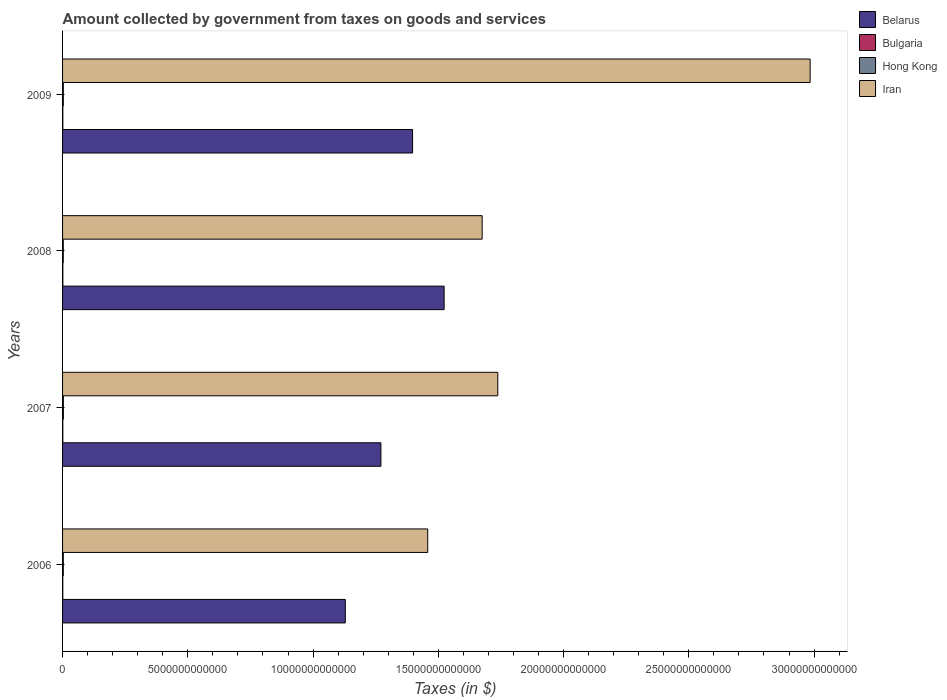How many different coloured bars are there?
Keep it short and to the point. 4. How many groups of bars are there?
Make the answer very short. 4. Are the number of bars per tick equal to the number of legend labels?
Your answer should be compact. Yes. How many bars are there on the 4th tick from the bottom?
Your response must be concise. 4. What is the amount collected by government from taxes on goods and services in Hong Kong in 2009?
Ensure brevity in your answer.  2.89e+1. Across all years, what is the maximum amount collected by government from taxes on goods and services in Bulgaria?
Keep it short and to the point. 1.17e+1. Across all years, what is the minimum amount collected by government from taxes on goods and services in Iran?
Give a very brief answer. 1.46e+13. In which year was the amount collected by government from taxes on goods and services in Belarus maximum?
Keep it short and to the point. 2008. In which year was the amount collected by government from taxes on goods and services in Iran minimum?
Offer a very short reply. 2006. What is the total amount collected by government from taxes on goods and services in Belarus in the graph?
Your response must be concise. 5.32e+13. What is the difference between the amount collected by government from taxes on goods and services in Bulgaria in 2007 and that in 2008?
Offer a terse response. -1.63e+09. What is the difference between the amount collected by government from taxes on goods and services in Iran in 2008 and the amount collected by government from taxes on goods and services in Bulgaria in 2007?
Offer a terse response. 1.67e+13. What is the average amount collected by government from taxes on goods and services in Bulgaria per year?
Keep it short and to the point. 1.02e+1. In the year 2008, what is the difference between the amount collected by government from taxes on goods and services in Hong Kong and amount collected by government from taxes on goods and services in Iran?
Your response must be concise. -1.67e+13. In how many years, is the amount collected by government from taxes on goods and services in Iran greater than 17000000000000 $?
Your answer should be compact. 2. What is the ratio of the amount collected by government from taxes on goods and services in Hong Kong in 2007 to that in 2008?
Your answer should be very brief. 1.12. Is the amount collected by government from taxes on goods and services in Belarus in 2006 less than that in 2009?
Ensure brevity in your answer.  Yes. Is the difference between the amount collected by government from taxes on goods and services in Hong Kong in 2006 and 2009 greater than the difference between the amount collected by government from taxes on goods and services in Iran in 2006 and 2009?
Make the answer very short. Yes. What is the difference between the highest and the second highest amount collected by government from taxes on goods and services in Belarus?
Offer a very short reply. 1.26e+12. What is the difference between the highest and the lowest amount collected by government from taxes on goods and services in Hong Kong?
Offer a terse response. 3.51e+09. In how many years, is the amount collected by government from taxes on goods and services in Iran greater than the average amount collected by government from taxes on goods and services in Iran taken over all years?
Offer a terse response. 1. Is the sum of the amount collected by government from taxes on goods and services in Bulgaria in 2006 and 2008 greater than the maximum amount collected by government from taxes on goods and services in Belarus across all years?
Keep it short and to the point. No. Is it the case that in every year, the sum of the amount collected by government from taxes on goods and services in Hong Kong and amount collected by government from taxes on goods and services in Bulgaria is greater than the sum of amount collected by government from taxes on goods and services in Belarus and amount collected by government from taxes on goods and services in Iran?
Offer a very short reply. No. What does the 2nd bar from the top in 2006 represents?
Provide a short and direct response. Hong Kong. What does the 1st bar from the bottom in 2007 represents?
Make the answer very short. Belarus. How many bars are there?
Make the answer very short. 16. Are all the bars in the graph horizontal?
Make the answer very short. Yes. What is the difference between two consecutive major ticks on the X-axis?
Your answer should be compact. 5.00e+12. Are the values on the major ticks of X-axis written in scientific E-notation?
Your answer should be very brief. No. Does the graph contain any zero values?
Give a very brief answer. No. Does the graph contain grids?
Your answer should be very brief. No. How many legend labels are there?
Ensure brevity in your answer.  4. How are the legend labels stacked?
Give a very brief answer. Vertical. What is the title of the graph?
Keep it short and to the point. Amount collected by government from taxes on goods and services. Does "Malta" appear as one of the legend labels in the graph?
Your answer should be compact. No. What is the label or title of the X-axis?
Provide a short and direct response. Taxes (in $). What is the label or title of the Y-axis?
Provide a succinct answer. Years. What is the Taxes (in $) in Belarus in 2006?
Offer a terse response. 1.13e+13. What is the Taxes (in $) in Bulgaria in 2006?
Your response must be concise. 8.53e+09. What is the Taxes (in $) in Hong Kong in 2006?
Ensure brevity in your answer.  2.92e+1. What is the Taxes (in $) of Iran in 2006?
Keep it short and to the point. 1.46e+13. What is the Taxes (in $) of Belarus in 2007?
Your answer should be compact. 1.27e+13. What is the Taxes (in $) of Bulgaria in 2007?
Ensure brevity in your answer.  1.01e+1. What is the Taxes (in $) of Hong Kong in 2007?
Offer a terse response. 3.20e+1. What is the Taxes (in $) of Iran in 2007?
Offer a very short reply. 1.74e+13. What is the Taxes (in $) in Belarus in 2008?
Ensure brevity in your answer.  1.52e+13. What is the Taxes (in $) of Bulgaria in 2008?
Your answer should be compact. 1.17e+1. What is the Taxes (in $) of Hong Kong in 2008?
Provide a succinct answer. 2.85e+1. What is the Taxes (in $) of Iran in 2008?
Keep it short and to the point. 1.68e+13. What is the Taxes (in $) of Belarus in 2009?
Your answer should be very brief. 1.40e+13. What is the Taxes (in $) of Bulgaria in 2009?
Make the answer very short. 1.04e+1. What is the Taxes (in $) of Hong Kong in 2009?
Give a very brief answer. 2.89e+1. What is the Taxes (in $) in Iran in 2009?
Provide a short and direct response. 2.98e+13. Across all years, what is the maximum Taxes (in $) of Belarus?
Your response must be concise. 1.52e+13. Across all years, what is the maximum Taxes (in $) in Bulgaria?
Make the answer very short. 1.17e+1. Across all years, what is the maximum Taxes (in $) in Hong Kong?
Offer a terse response. 3.20e+1. Across all years, what is the maximum Taxes (in $) in Iran?
Your answer should be compact. 2.98e+13. Across all years, what is the minimum Taxes (in $) of Belarus?
Your answer should be very brief. 1.13e+13. Across all years, what is the minimum Taxes (in $) of Bulgaria?
Your answer should be very brief. 8.53e+09. Across all years, what is the minimum Taxes (in $) in Hong Kong?
Keep it short and to the point. 2.85e+1. Across all years, what is the minimum Taxes (in $) of Iran?
Offer a very short reply. 1.46e+13. What is the total Taxes (in $) in Belarus in the graph?
Offer a very short reply. 5.32e+13. What is the total Taxes (in $) of Bulgaria in the graph?
Ensure brevity in your answer.  4.08e+1. What is the total Taxes (in $) in Hong Kong in the graph?
Your answer should be very brief. 1.19e+11. What is the total Taxes (in $) of Iran in the graph?
Ensure brevity in your answer.  7.85e+13. What is the difference between the Taxes (in $) in Belarus in 2006 and that in 2007?
Keep it short and to the point. -1.42e+12. What is the difference between the Taxes (in $) of Bulgaria in 2006 and that in 2007?
Offer a very short reply. -1.56e+09. What is the difference between the Taxes (in $) of Hong Kong in 2006 and that in 2007?
Your answer should be very brief. -2.78e+09. What is the difference between the Taxes (in $) in Iran in 2006 and that in 2007?
Provide a short and direct response. -2.80e+12. What is the difference between the Taxes (in $) in Belarus in 2006 and that in 2008?
Your response must be concise. -3.95e+12. What is the difference between the Taxes (in $) of Bulgaria in 2006 and that in 2008?
Keep it short and to the point. -3.19e+09. What is the difference between the Taxes (in $) in Hong Kong in 2006 and that in 2008?
Offer a terse response. 7.30e+08. What is the difference between the Taxes (in $) of Iran in 2006 and that in 2008?
Offer a very short reply. -2.17e+12. What is the difference between the Taxes (in $) in Belarus in 2006 and that in 2009?
Your answer should be very brief. -2.69e+12. What is the difference between the Taxes (in $) of Bulgaria in 2006 and that in 2009?
Offer a very short reply. -1.91e+09. What is the difference between the Taxes (in $) in Hong Kong in 2006 and that in 2009?
Your answer should be very brief. 3.08e+08. What is the difference between the Taxes (in $) in Iran in 2006 and that in 2009?
Your response must be concise. -1.53e+13. What is the difference between the Taxes (in $) in Belarus in 2007 and that in 2008?
Make the answer very short. -2.52e+12. What is the difference between the Taxes (in $) in Bulgaria in 2007 and that in 2008?
Ensure brevity in your answer.  -1.63e+09. What is the difference between the Taxes (in $) in Hong Kong in 2007 and that in 2008?
Make the answer very short. 3.51e+09. What is the difference between the Taxes (in $) in Iran in 2007 and that in 2008?
Ensure brevity in your answer.  6.24e+11. What is the difference between the Taxes (in $) of Belarus in 2007 and that in 2009?
Your answer should be compact. -1.26e+12. What is the difference between the Taxes (in $) in Bulgaria in 2007 and that in 2009?
Offer a terse response. -3.42e+08. What is the difference between the Taxes (in $) in Hong Kong in 2007 and that in 2009?
Provide a short and direct response. 3.09e+09. What is the difference between the Taxes (in $) in Iran in 2007 and that in 2009?
Make the answer very short. -1.25e+13. What is the difference between the Taxes (in $) in Belarus in 2008 and that in 2009?
Provide a short and direct response. 1.26e+12. What is the difference between the Taxes (in $) in Bulgaria in 2008 and that in 2009?
Your answer should be compact. 1.29e+09. What is the difference between the Taxes (in $) of Hong Kong in 2008 and that in 2009?
Your answer should be compact. -4.22e+08. What is the difference between the Taxes (in $) in Iran in 2008 and that in 2009?
Offer a terse response. -1.31e+13. What is the difference between the Taxes (in $) in Belarus in 2006 and the Taxes (in $) in Bulgaria in 2007?
Provide a short and direct response. 1.13e+13. What is the difference between the Taxes (in $) in Belarus in 2006 and the Taxes (in $) in Hong Kong in 2007?
Offer a terse response. 1.13e+13. What is the difference between the Taxes (in $) of Belarus in 2006 and the Taxes (in $) of Iran in 2007?
Provide a short and direct response. -6.09e+12. What is the difference between the Taxes (in $) in Bulgaria in 2006 and the Taxes (in $) in Hong Kong in 2007?
Make the answer very short. -2.34e+1. What is the difference between the Taxes (in $) in Bulgaria in 2006 and the Taxes (in $) in Iran in 2007?
Keep it short and to the point. -1.74e+13. What is the difference between the Taxes (in $) of Hong Kong in 2006 and the Taxes (in $) of Iran in 2007?
Your answer should be compact. -1.73e+13. What is the difference between the Taxes (in $) of Belarus in 2006 and the Taxes (in $) of Bulgaria in 2008?
Your answer should be compact. 1.13e+13. What is the difference between the Taxes (in $) of Belarus in 2006 and the Taxes (in $) of Hong Kong in 2008?
Offer a very short reply. 1.13e+13. What is the difference between the Taxes (in $) of Belarus in 2006 and the Taxes (in $) of Iran in 2008?
Provide a succinct answer. -5.46e+12. What is the difference between the Taxes (in $) of Bulgaria in 2006 and the Taxes (in $) of Hong Kong in 2008?
Give a very brief answer. -1.99e+1. What is the difference between the Taxes (in $) in Bulgaria in 2006 and the Taxes (in $) in Iran in 2008?
Your response must be concise. -1.67e+13. What is the difference between the Taxes (in $) of Hong Kong in 2006 and the Taxes (in $) of Iran in 2008?
Your response must be concise. -1.67e+13. What is the difference between the Taxes (in $) in Belarus in 2006 and the Taxes (in $) in Bulgaria in 2009?
Provide a short and direct response. 1.13e+13. What is the difference between the Taxes (in $) of Belarus in 2006 and the Taxes (in $) of Hong Kong in 2009?
Provide a succinct answer. 1.13e+13. What is the difference between the Taxes (in $) in Belarus in 2006 and the Taxes (in $) in Iran in 2009?
Provide a short and direct response. -1.86e+13. What is the difference between the Taxes (in $) in Bulgaria in 2006 and the Taxes (in $) in Hong Kong in 2009?
Provide a short and direct response. -2.04e+1. What is the difference between the Taxes (in $) in Bulgaria in 2006 and the Taxes (in $) in Iran in 2009?
Your answer should be very brief. -2.98e+13. What is the difference between the Taxes (in $) in Hong Kong in 2006 and the Taxes (in $) in Iran in 2009?
Provide a succinct answer. -2.98e+13. What is the difference between the Taxes (in $) in Belarus in 2007 and the Taxes (in $) in Bulgaria in 2008?
Make the answer very short. 1.27e+13. What is the difference between the Taxes (in $) of Belarus in 2007 and the Taxes (in $) of Hong Kong in 2008?
Your answer should be very brief. 1.27e+13. What is the difference between the Taxes (in $) of Belarus in 2007 and the Taxes (in $) of Iran in 2008?
Provide a short and direct response. -4.04e+12. What is the difference between the Taxes (in $) in Bulgaria in 2007 and the Taxes (in $) in Hong Kong in 2008?
Provide a succinct answer. -1.84e+1. What is the difference between the Taxes (in $) in Bulgaria in 2007 and the Taxes (in $) in Iran in 2008?
Keep it short and to the point. -1.67e+13. What is the difference between the Taxes (in $) of Hong Kong in 2007 and the Taxes (in $) of Iran in 2008?
Your response must be concise. -1.67e+13. What is the difference between the Taxes (in $) of Belarus in 2007 and the Taxes (in $) of Bulgaria in 2009?
Make the answer very short. 1.27e+13. What is the difference between the Taxes (in $) of Belarus in 2007 and the Taxes (in $) of Hong Kong in 2009?
Your answer should be compact. 1.27e+13. What is the difference between the Taxes (in $) of Belarus in 2007 and the Taxes (in $) of Iran in 2009?
Your answer should be very brief. -1.71e+13. What is the difference between the Taxes (in $) of Bulgaria in 2007 and the Taxes (in $) of Hong Kong in 2009?
Offer a terse response. -1.88e+1. What is the difference between the Taxes (in $) of Bulgaria in 2007 and the Taxes (in $) of Iran in 2009?
Your answer should be compact. -2.98e+13. What is the difference between the Taxes (in $) of Hong Kong in 2007 and the Taxes (in $) of Iran in 2009?
Offer a terse response. -2.98e+13. What is the difference between the Taxes (in $) of Belarus in 2008 and the Taxes (in $) of Bulgaria in 2009?
Your answer should be compact. 1.52e+13. What is the difference between the Taxes (in $) in Belarus in 2008 and the Taxes (in $) in Hong Kong in 2009?
Offer a terse response. 1.52e+13. What is the difference between the Taxes (in $) of Belarus in 2008 and the Taxes (in $) of Iran in 2009?
Ensure brevity in your answer.  -1.46e+13. What is the difference between the Taxes (in $) of Bulgaria in 2008 and the Taxes (in $) of Hong Kong in 2009?
Make the answer very short. -1.72e+1. What is the difference between the Taxes (in $) in Bulgaria in 2008 and the Taxes (in $) in Iran in 2009?
Provide a succinct answer. -2.98e+13. What is the difference between the Taxes (in $) in Hong Kong in 2008 and the Taxes (in $) in Iran in 2009?
Ensure brevity in your answer.  -2.98e+13. What is the average Taxes (in $) in Belarus per year?
Offer a terse response. 1.33e+13. What is the average Taxes (in $) in Bulgaria per year?
Your answer should be very brief. 1.02e+1. What is the average Taxes (in $) of Hong Kong per year?
Your answer should be compact. 2.96e+1. What is the average Taxes (in $) of Iran per year?
Give a very brief answer. 1.96e+13. In the year 2006, what is the difference between the Taxes (in $) in Belarus and Taxes (in $) in Bulgaria?
Provide a succinct answer. 1.13e+13. In the year 2006, what is the difference between the Taxes (in $) in Belarus and Taxes (in $) in Hong Kong?
Offer a very short reply. 1.13e+13. In the year 2006, what is the difference between the Taxes (in $) in Belarus and Taxes (in $) in Iran?
Your answer should be very brief. -3.29e+12. In the year 2006, what is the difference between the Taxes (in $) of Bulgaria and Taxes (in $) of Hong Kong?
Offer a terse response. -2.07e+1. In the year 2006, what is the difference between the Taxes (in $) in Bulgaria and Taxes (in $) in Iran?
Ensure brevity in your answer.  -1.46e+13. In the year 2006, what is the difference between the Taxes (in $) in Hong Kong and Taxes (in $) in Iran?
Offer a very short reply. -1.45e+13. In the year 2007, what is the difference between the Taxes (in $) of Belarus and Taxes (in $) of Bulgaria?
Your answer should be very brief. 1.27e+13. In the year 2007, what is the difference between the Taxes (in $) in Belarus and Taxes (in $) in Hong Kong?
Offer a terse response. 1.27e+13. In the year 2007, what is the difference between the Taxes (in $) of Belarus and Taxes (in $) of Iran?
Provide a succinct answer. -4.67e+12. In the year 2007, what is the difference between the Taxes (in $) in Bulgaria and Taxes (in $) in Hong Kong?
Provide a short and direct response. -2.19e+1. In the year 2007, what is the difference between the Taxes (in $) of Bulgaria and Taxes (in $) of Iran?
Provide a short and direct response. -1.74e+13. In the year 2007, what is the difference between the Taxes (in $) of Hong Kong and Taxes (in $) of Iran?
Give a very brief answer. -1.73e+13. In the year 2008, what is the difference between the Taxes (in $) of Belarus and Taxes (in $) of Bulgaria?
Make the answer very short. 1.52e+13. In the year 2008, what is the difference between the Taxes (in $) of Belarus and Taxes (in $) of Hong Kong?
Provide a short and direct response. 1.52e+13. In the year 2008, what is the difference between the Taxes (in $) in Belarus and Taxes (in $) in Iran?
Give a very brief answer. -1.52e+12. In the year 2008, what is the difference between the Taxes (in $) in Bulgaria and Taxes (in $) in Hong Kong?
Your answer should be compact. -1.67e+1. In the year 2008, what is the difference between the Taxes (in $) in Bulgaria and Taxes (in $) in Iran?
Keep it short and to the point. -1.67e+13. In the year 2008, what is the difference between the Taxes (in $) in Hong Kong and Taxes (in $) in Iran?
Offer a terse response. -1.67e+13. In the year 2009, what is the difference between the Taxes (in $) in Belarus and Taxes (in $) in Bulgaria?
Your answer should be compact. 1.40e+13. In the year 2009, what is the difference between the Taxes (in $) of Belarus and Taxes (in $) of Hong Kong?
Make the answer very short. 1.39e+13. In the year 2009, what is the difference between the Taxes (in $) of Belarus and Taxes (in $) of Iran?
Your response must be concise. -1.59e+13. In the year 2009, what is the difference between the Taxes (in $) in Bulgaria and Taxes (in $) in Hong Kong?
Your answer should be very brief. -1.84e+1. In the year 2009, what is the difference between the Taxes (in $) in Bulgaria and Taxes (in $) in Iran?
Give a very brief answer. -2.98e+13. In the year 2009, what is the difference between the Taxes (in $) of Hong Kong and Taxes (in $) of Iran?
Offer a very short reply. -2.98e+13. What is the ratio of the Taxes (in $) in Belarus in 2006 to that in 2007?
Ensure brevity in your answer.  0.89. What is the ratio of the Taxes (in $) in Bulgaria in 2006 to that in 2007?
Give a very brief answer. 0.85. What is the ratio of the Taxes (in $) in Hong Kong in 2006 to that in 2007?
Provide a succinct answer. 0.91. What is the ratio of the Taxes (in $) in Iran in 2006 to that in 2007?
Your answer should be very brief. 0.84. What is the ratio of the Taxes (in $) in Belarus in 2006 to that in 2008?
Your answer should be compact. 0.74. What is the ratio of the Taxes (in $) in Bulgaria in 2006 to that in 2008?
Offer a terse response. 0.73. What is the ratio of the Taxes (in $) of Hong Kong in 2006 to that in 2008?
Make the answer very short. 1.03. What is the ratio of the Taxes (in $) in Iran in 2006 to that in 2008?
Keep it short and to the point. 0.87. What is the ratio of the Taxes (in $) of Belarus in 2006 to that in 2009?
Ensure brevity in your answer.  0.81. What is the ratio of the Taxes (in $) of Bulgaria in 2006 to that in 2009?
Provide a succinct answer. 0.82. What is the ratio of the Taxes (in $) in Hong Kong in 2006 to that in 2009?
Give a very brief answer. 1.01. What is the ratio of the Taxes (in $) in Iran in 2006 to that in 2009?
Offer a terse response. 0.49. What is the ratio of the Taxes (in $) in Belarus in 2007 to that in 2008?
Provide a succinct answer. 0.83. What is the ratio of the Taxes (in $) of Bulgaria in 2007 to that in 2008?
Your answer should be very brief. 0.86. What is the ratio of the Taxes (in $) of Hong Kong in 2007 to that in 2008?
Make the answer very short. 1.12. What is the ratio of the Taxes (in $) of Iran in 2007 to that in 2008?
Give a very brief answer. 1.04. What is the ratio of the Taxes (in $) of Belarus in 2007 to that in 2009?
Provide a succinct answer. 0.91. What is the ratio of the Taxes (in $) in Bulgaria in 2007 to that in 2009?
Keep it short and to the point. 0.97. What is the ratio of the Taxes (in $) of Hong Kong in 2007 to that in 2009?
Your answer should be very brief. 1.11. What is the ratio of the Taxes (in $) of Iran in 2007 to that in 2009?
Offer a terse response. 0.58. What is the ratio of the Taxes (in $) in Belarus in 2008 to that in 2009?
Your answer should be very brief. 1.09. What is the ratio of the Taxes (in $) of Bulgaria in 2008 to that in 2009?
Give a very brief answer. 1.12. What is the ratio of the Taxes (in $) in Hong Kong in 2008 to that in 2009?
Offer a terse response. 0.99. What is the ratio of the Taxes (in $) of Iran in 2008 to that in 2009?
Ensure brevity in your answer.  0.56. What is the difference between the highest and the second highest Taxes (in $) of Belarus?
Ensure brevity in your answer.  1.26e+12. What is the difference between the highest and the second highest Taxes (in $) of Bulgaria?
Ensure brevity in your answer.  1.29e+09. What is the difference between the highest and the second highest Taxes (in $) in Hong Kong?
Your response must be concise. 2.78e+09. What is the difference between the highest and the second highest Taxes (in $) of Iran?
Offer a very short reply. 1.25e+13. What is the difference between the highest and the lowest Taxes (in $) of Belarus?
Make the answer very short. 3.95e+12. What is the difference between the highest and the lowest Taxes (in $) in Bulgaria?
Your response must be concise. 3.19e+09. What is the difference between the highest and the lowest Taxes (in $) of Hong Kong?
Your answer should be compact. 3.51e+09. What is the difference between the highest and the lowest Taxes (in $) of Iran?
Your answer should be very brief. 1.53e+13. 